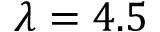<formula> <loc_0><loc_0><loc_500><loc_500>\lambda = 4 . 5</formula> 